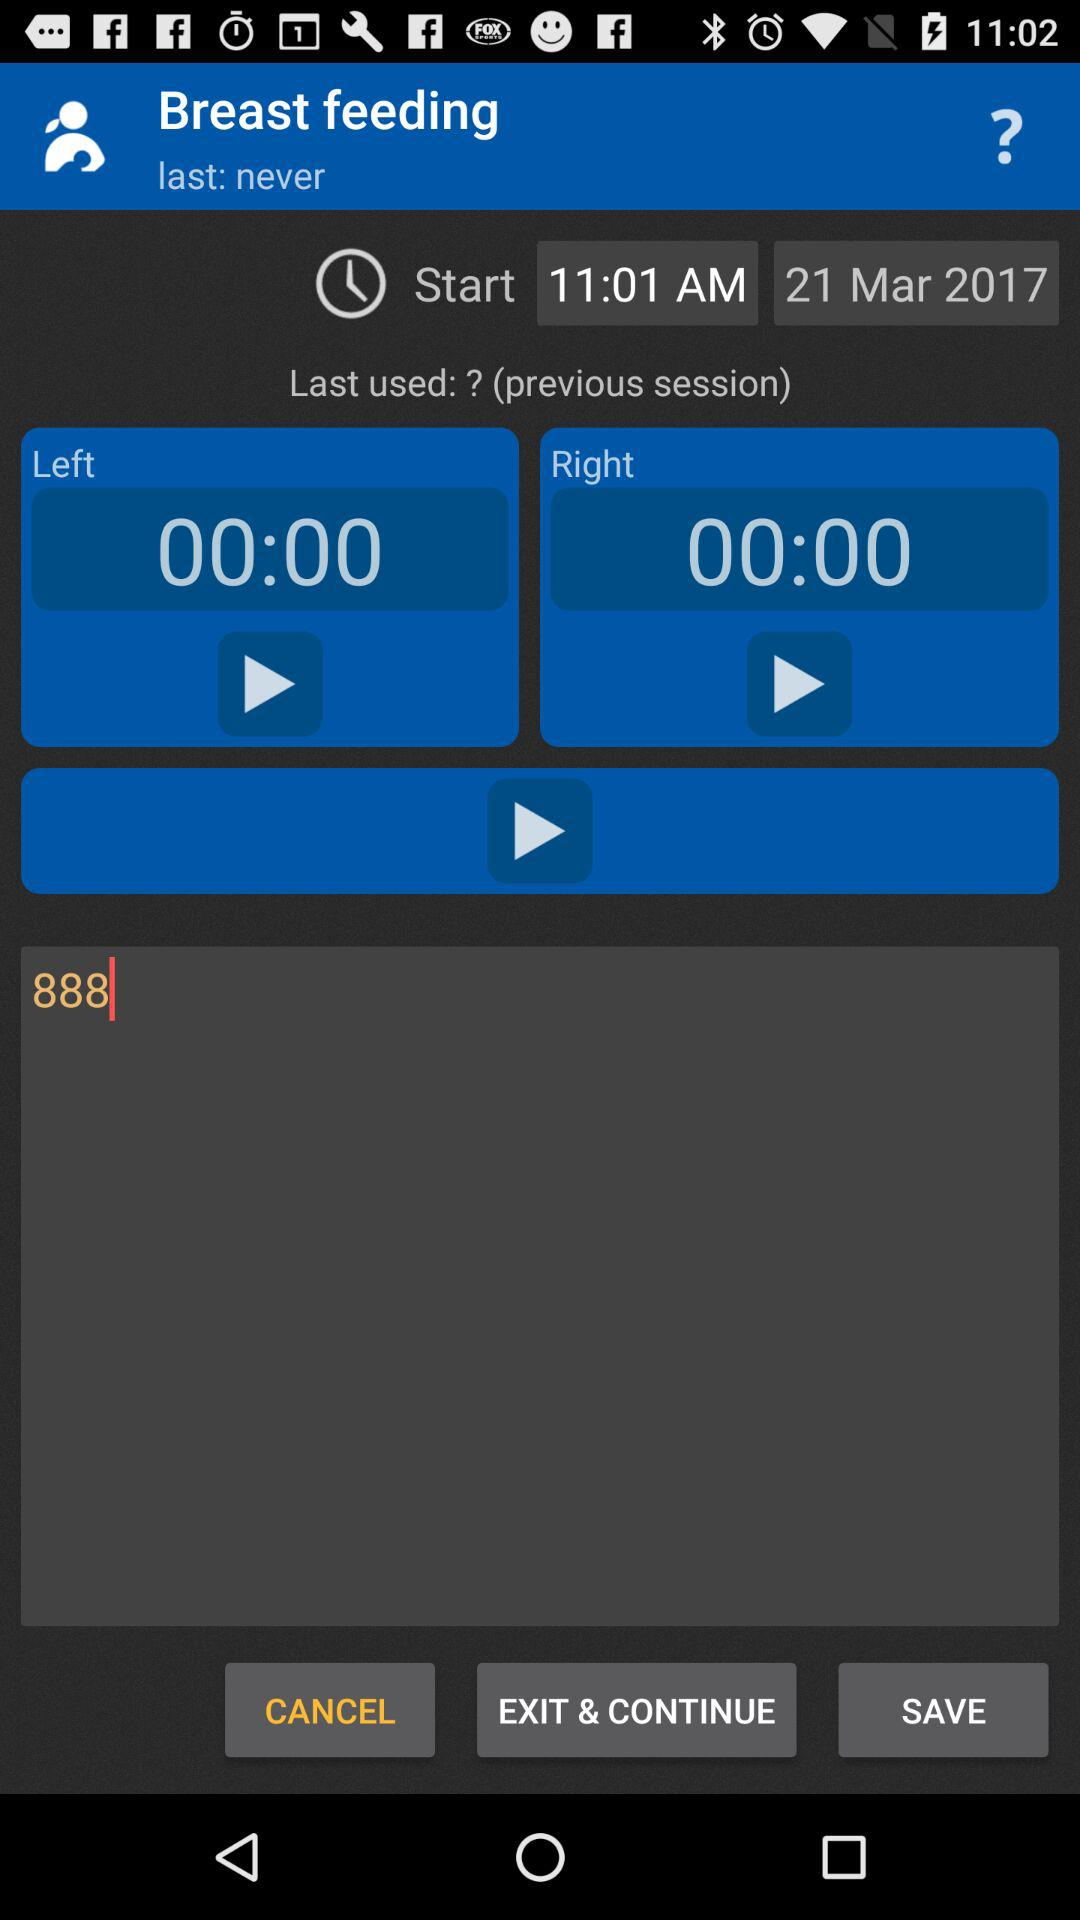What is the starting date for breastfeeding? The starting date for breastfeeding is March 21, 2017. 